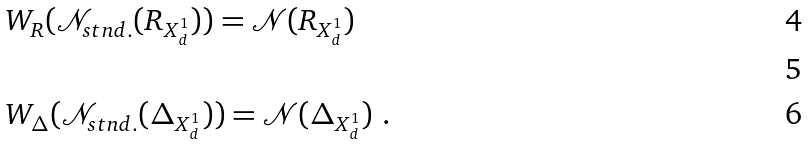Convert formula to latex. <formula><loc_0><loc_0><loc_500><loc_500>& W _ { R } ( \mathcal { N } _ { s t n d . } ( R _ { X ^ { 1 } _ { d } } ) ) = \mathcal { N } ( R _ { X ^ { 1 } _ { d } } ) \\ \ \\ & W _ { \Delta } ( \mathcal { N } _ { s t n d . } ( \Delta _ { X ^ { 1 } _ { d } } ) ) = \mathcal { N } ( \Delta _ { X ^ { 1 } _ { d } } ) \ .</formula> 